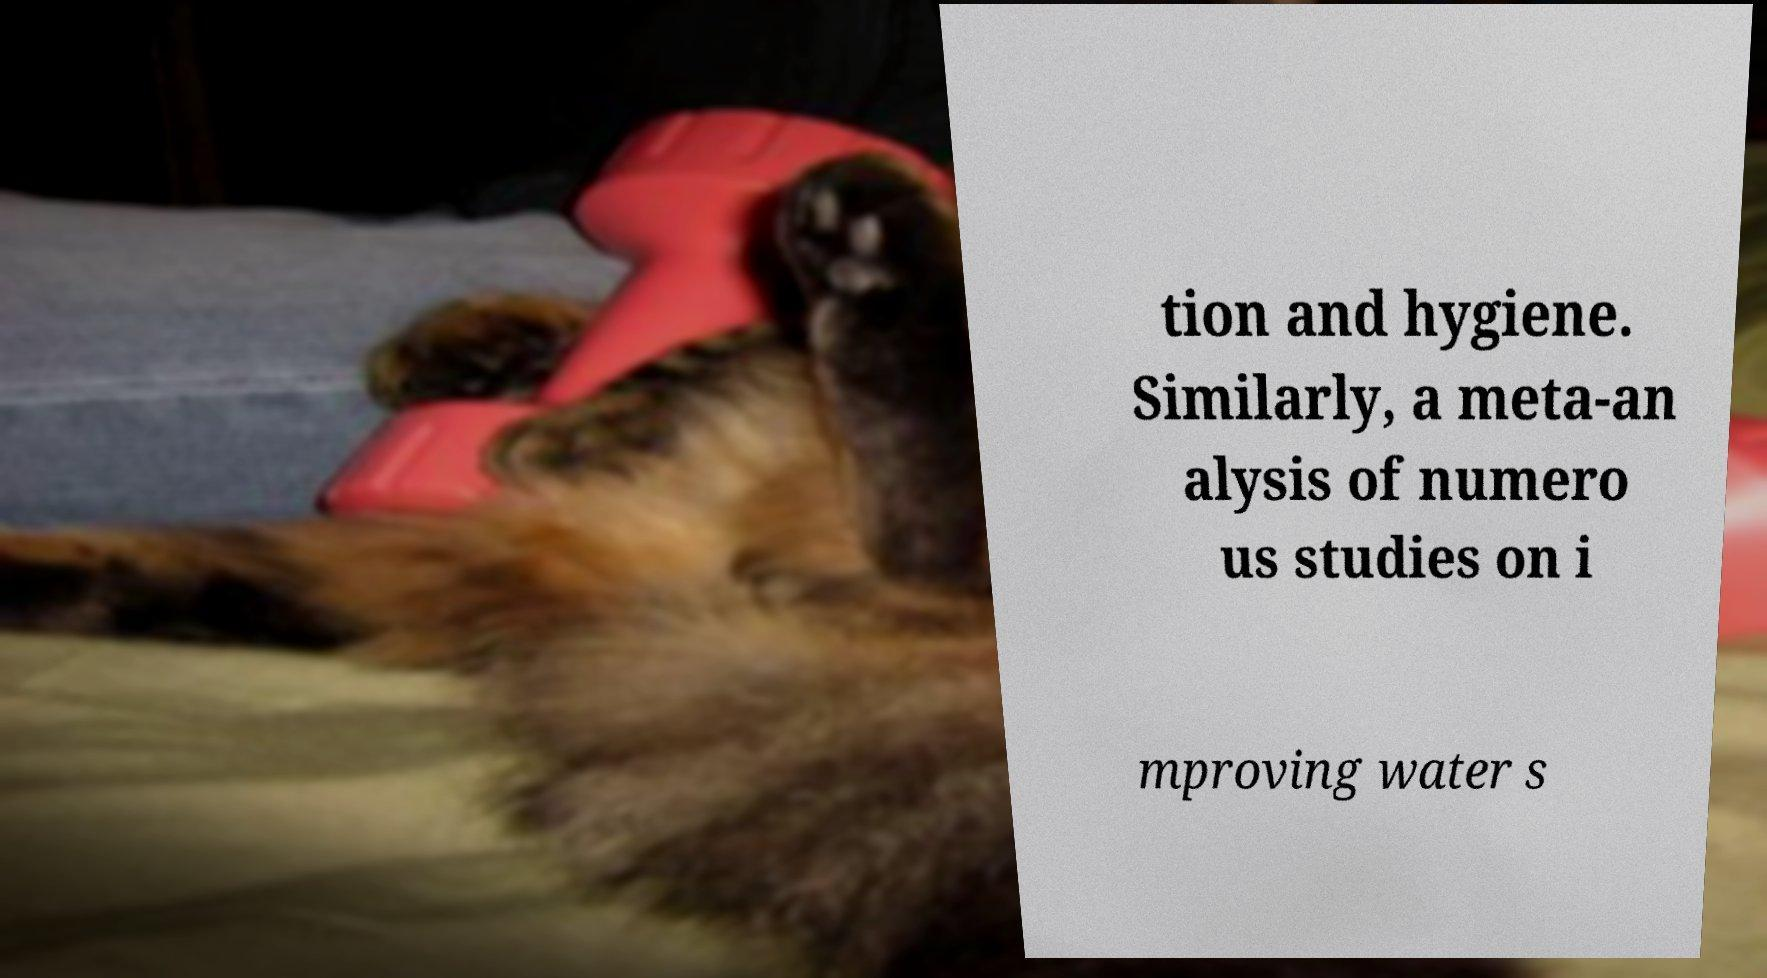For documentation purposes, I need the text within this image transcribed. Could you provide that? tion and hygiene. Similarly, a meta-an alysis of numero us studies on i mproving water s 